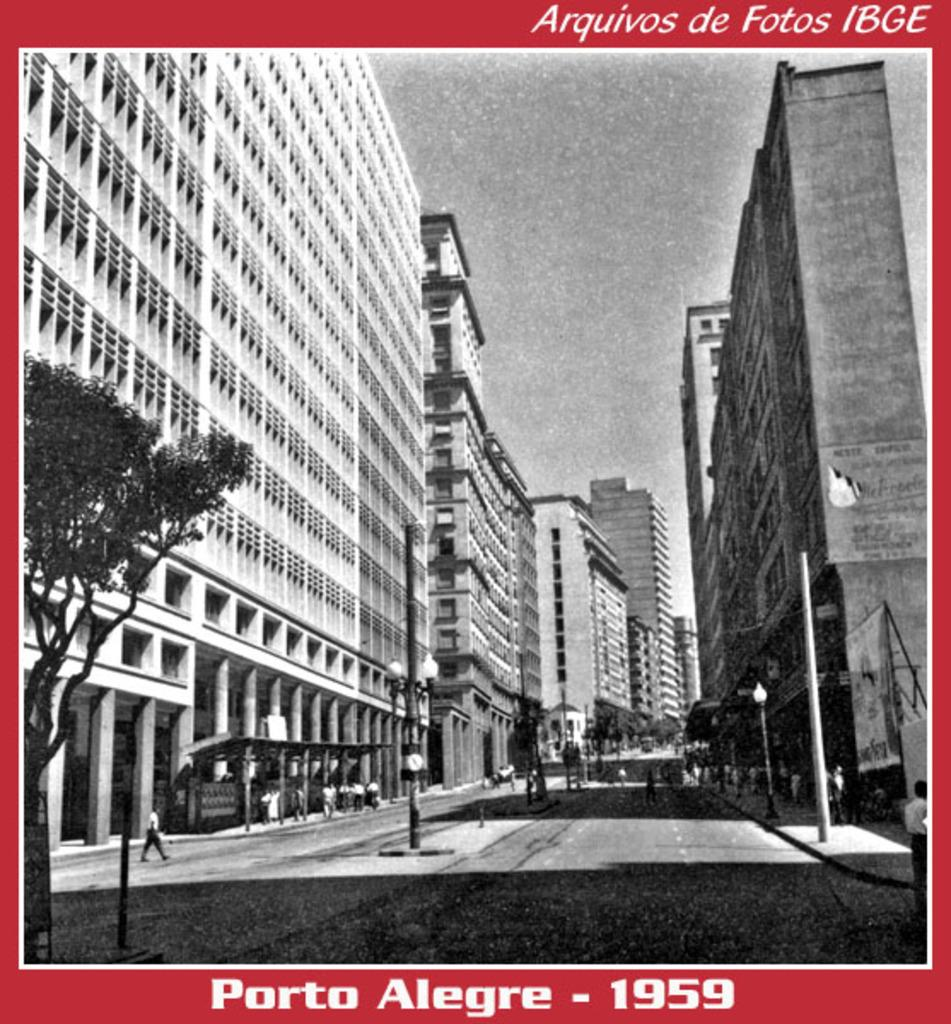What is present in the image that contains both images and text? There is a poster in the image that contains images and text. What type of owl can be seen flying through space in the image? There is no owl or space present in the image; it only contains a poster with images and text. 